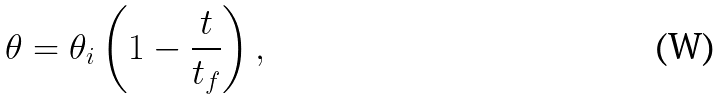<formula> <loc_0><loc_0><loc_500><loc_500>\theta = \theta _ { i } \left ( 1 - \frac { t } { t _ { f } } \right ) ,</formula> 